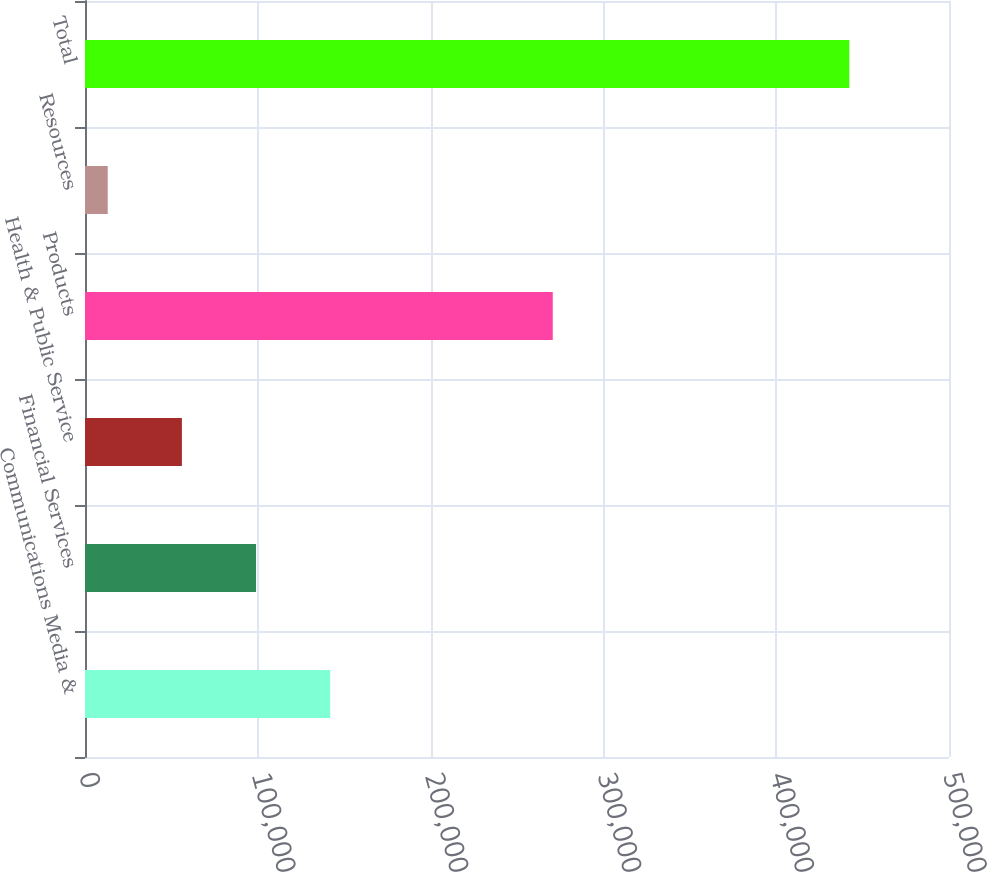Convert chart to OTSL. <chart><loc_0><loc_0><loc_500><loc_500><bar_chart><fcel>Communications Media &<fcel>Financial Services<fcel>Health & Public Service<fcel>Products<fcel>Resources<fcel>Total<nl><fcel>141902<fcel>98989<fcel>56076<fcel>270701<fcel>13163<fcel>442293<nl></chart> 